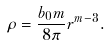<formula> <loc_0><loc_0><loc_500><loc_500>\rho = \frac { b _ { 0 } m } { 8 \pi } r ^ { m - 3 } .</formula> 